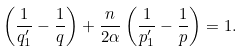<formula> <loc_0><loc_0><loc_500><loc_500>\left ( \frac { 1 } { q _ { 1 } ^ { \prime } } - \frac { 1 } { q } \right ) + \frac { n } { 2 \alpha } \left ( \frac { 1 } { p _ { 1 } ^ { \prime } } - \frac { 1 } { p } \right ) = 1 .</formula> 